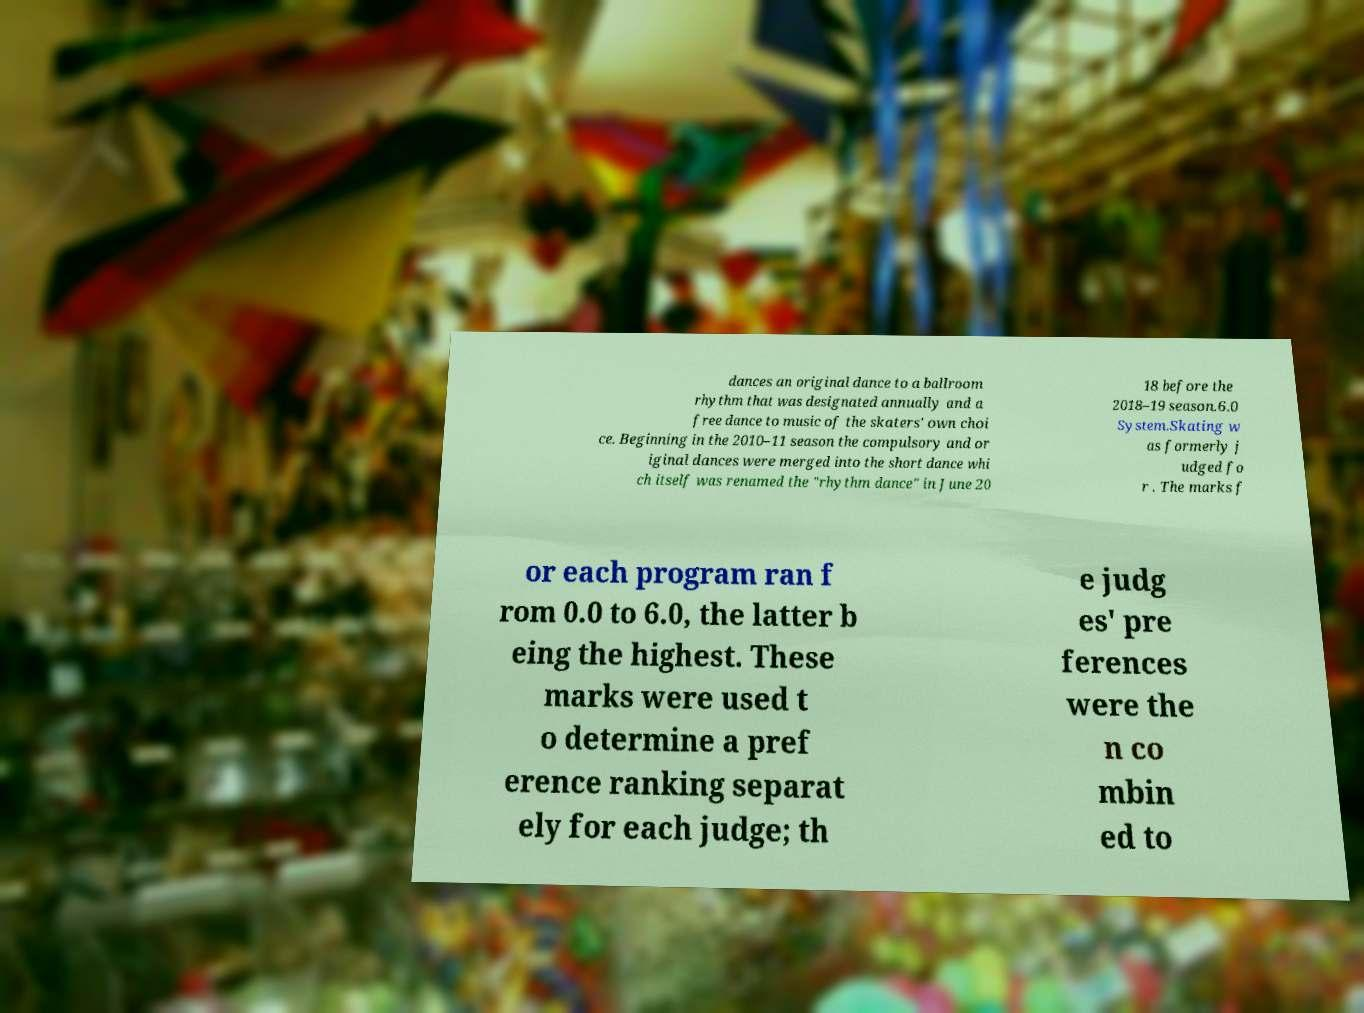Could you extract and type out the text from this image? dances an original dance to a ballroom rhythm that was designated annually and a free dance to music of the skaters' own choi ce. Beginning in the 2010–11 season the compulsory and or iginal dances were merged into the short dance whi ch itself was renamed the "rhythm dance" in June 20 18 before the 2018–19 season.6.0 System.Skating w as formerly j udged fo r . The marks f or each program ran f rom 0.0 to 6.0, the latter b eing the highest. These marks were used t o determine a pref erence ranking separat ely for each judge; th e judg es' pre ferences were the n co mbin ed to 